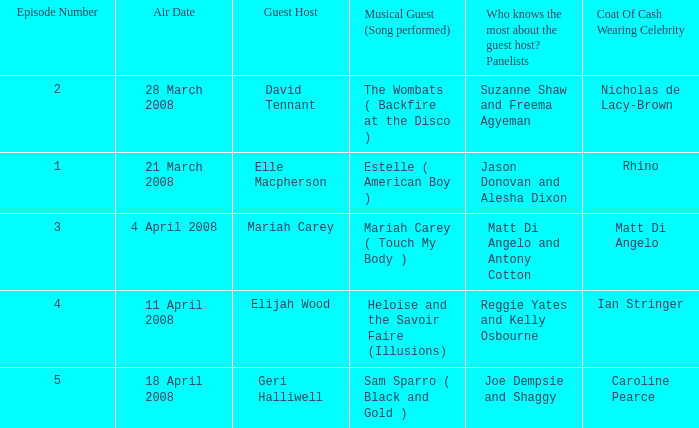Name the least number of episodes for the panelists of reggie yates and kelly osbourne 4.0. 